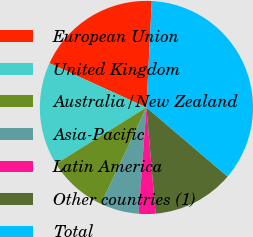Convert chart to OTSL. <chart><loc_0><loc_0><loc_500><loc_500><pie_chart><fcel>European Union<fcel>United Kingdom<fcel>Australia/New Zealand<fcel>Asia-Pacific<fcel>Latin America<fcel>Other countries (1)<fcel>Total<nl><fcel>18.99%<fcel>15.7%<fcel>9.12%<fcel>5.83%<fcel>2.54%<fcel>12.41%<fcel>35.43%<nl></chart> 